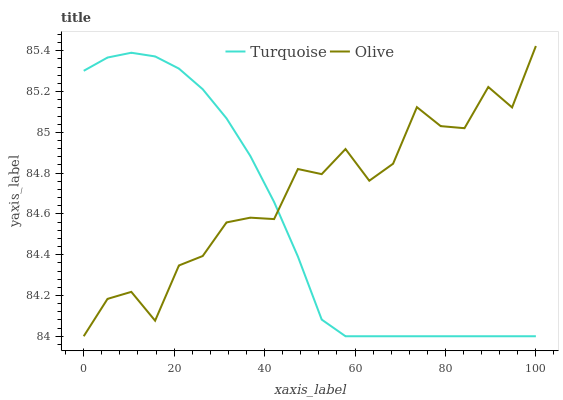Does Turquoise have the minimum area under the curve?
Answer yes or no. Yes. Does Olive have the maximum area under the curve?
Answer yes or no. Yes. Does Turquoise have the maximum area under the curve?
Answer yes or no. No. Is Turquoise the smoothest?
Answer yes or no. Yes. Is Olive the roughest?
Answer yes or no. Yes. Is Turquoise the roughest?
Answer yes or no. No. Does Olive have the lowest value?
Answer yes or no. Yes. Does Olive have the highest value?
Answer yes or no. Yes. Does Turquoise have the highest value?
Answer yes or no. No. Does Turquoise intersect Olive?
Answer yes or no. Yes. Is Turquoise less than Olive?
Answer yes or no. No. Is Turquoise greater than Olive?
Answer yes or no. No. 